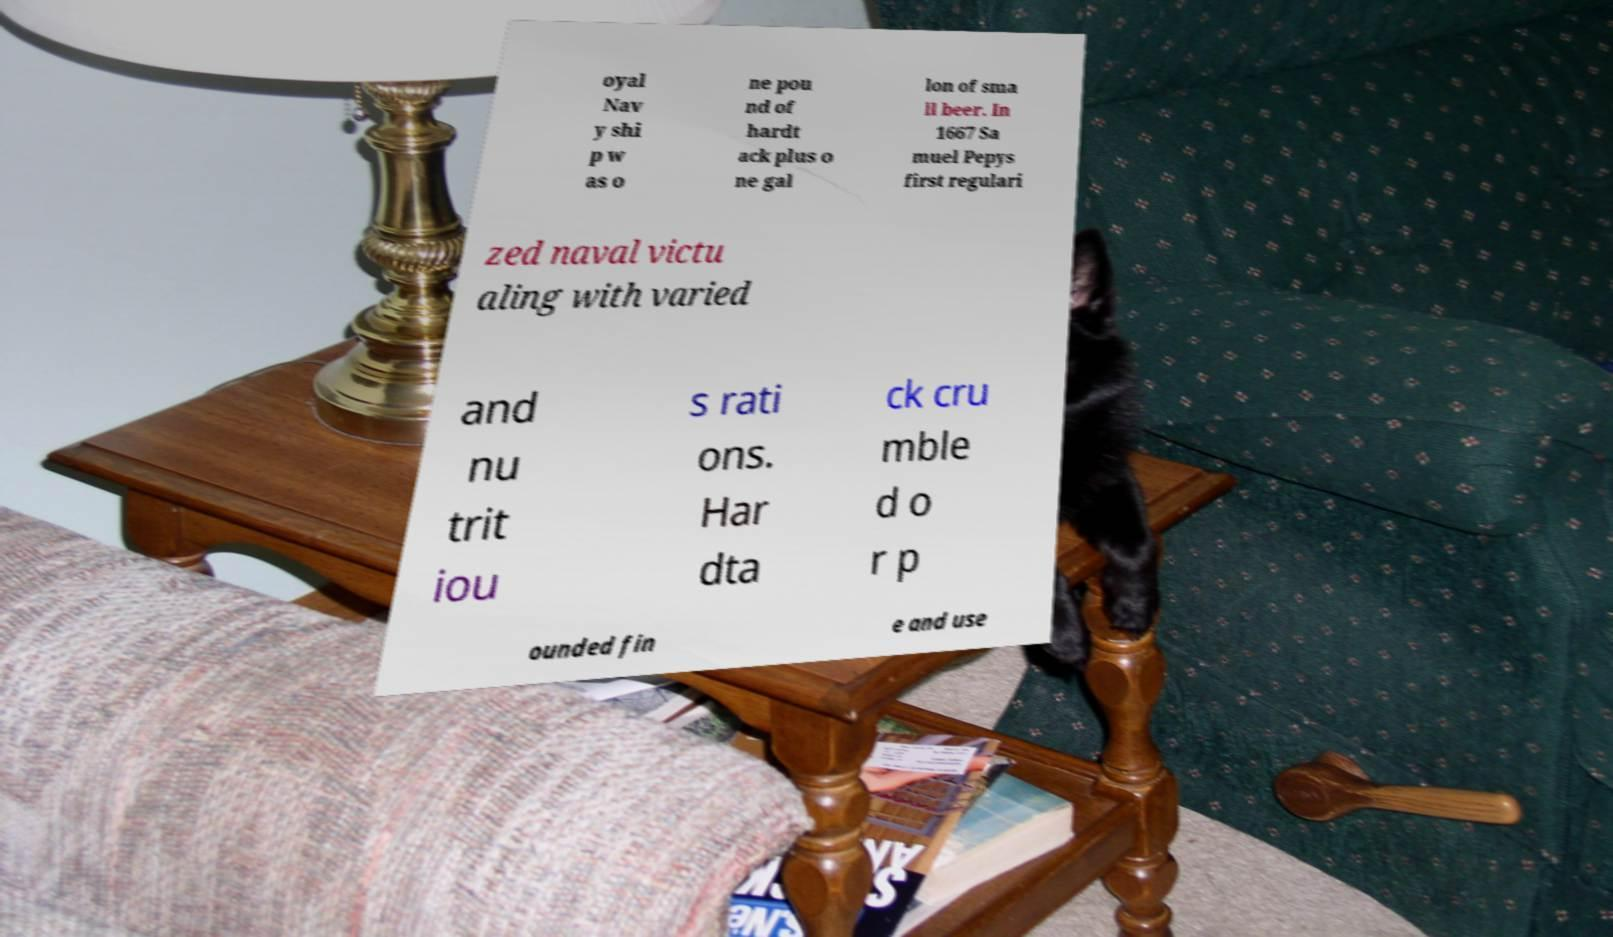What messages or text are displayed in this image? I need them in a readable, typed format. oyal Nav y shi p w as o ne pou nd of hardt ack plus o ne gal lon of sma ll beer. In 1667 Sa muel Pepys first regulari zed naval victu aling with varied and nu trit iou s rati ons. Har dta ck cru mble d o r p ounded fin e and use 